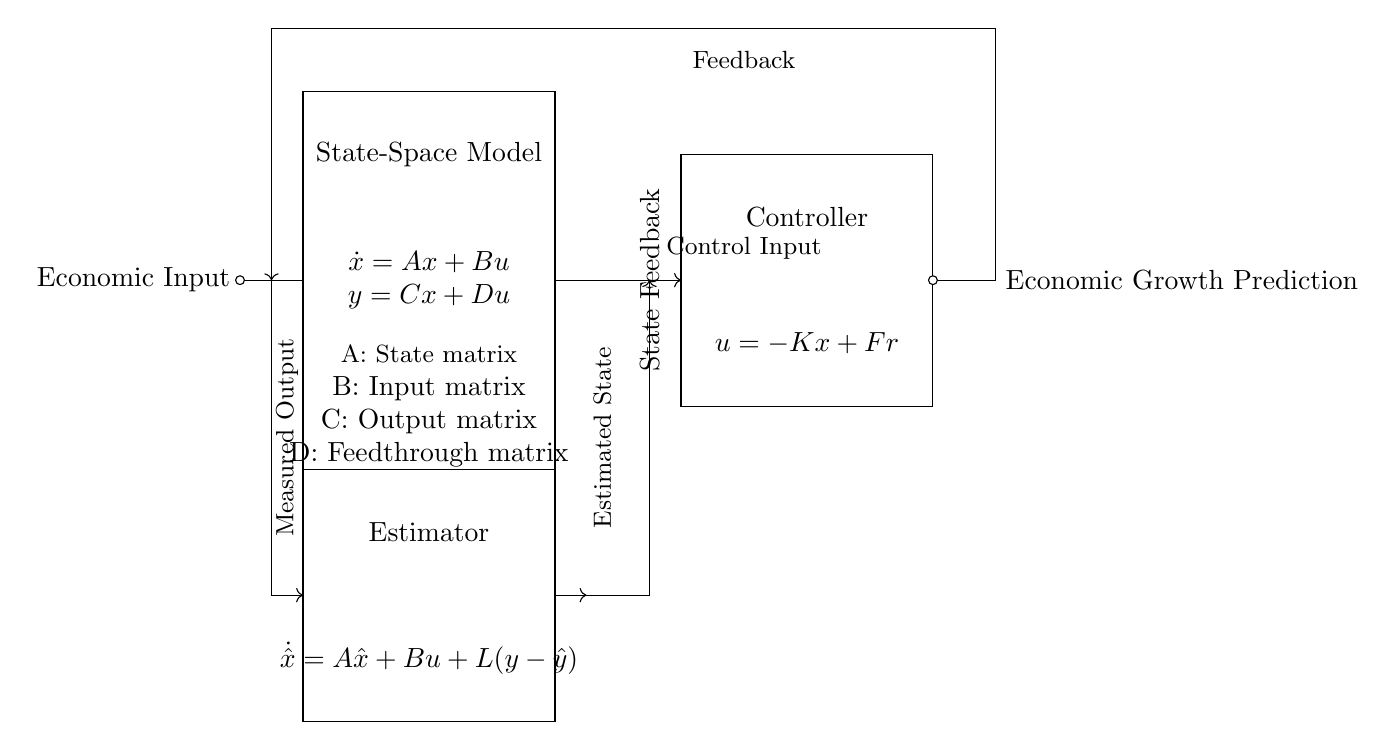What is the primary function of the state-space model? The state-space model serves as the mathematical representation of the control system that describes how state variables evolve over time based on inputs. It is shown by the equations $\dot{x} = Ax + Bu$ and $y = Cx + Du$.
Answer: mathematical representation What does the controller do in this circuit? The controller modifies the control input based on the state feedback and a reference input, represented by the equation $u = -Kx + Fr$. This feedback loop aims to adjust the system's behavior for desired outcomes.
Answer: modifies control input What is the purpose of the estimator in this circuit? The estimator calculates the estimated state of the system by combining the actual output measurement with feedback. It follows the equation $\dot{\hat{x}} = A\hat{x} + Bu + L(y - \hat{y})$, where the feedback helps reduce estimation error.
Answer: calculates estimated state How are the economic input and output related in this circuit? The economic input is processed through the state-space model which then generates a predicted economic growth output. This relationship is illustrated via the arrows connecting these elements in the circuit.
Answer: processed through state-space model What type of feedback is demonstrated in the circuit? The circuit displays state feedback, which utilizes the current state of the system to influence the control input. This feedback is critical for stabilizing and guiding the system towards desired economic growth values.
Answer: state feedback 